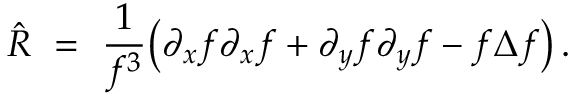Convert formula to latex. <formula><loc_0><loc_0><loc_500><loc_500>\hat { R } \ = \ \frac { 1 } { f ^ { 3 } } \left ( \partial _ { x } f \partial _ { x } f + \partial _ { y } f \partial _ { y } f - f \Delta f \right ) \, .</formula> 